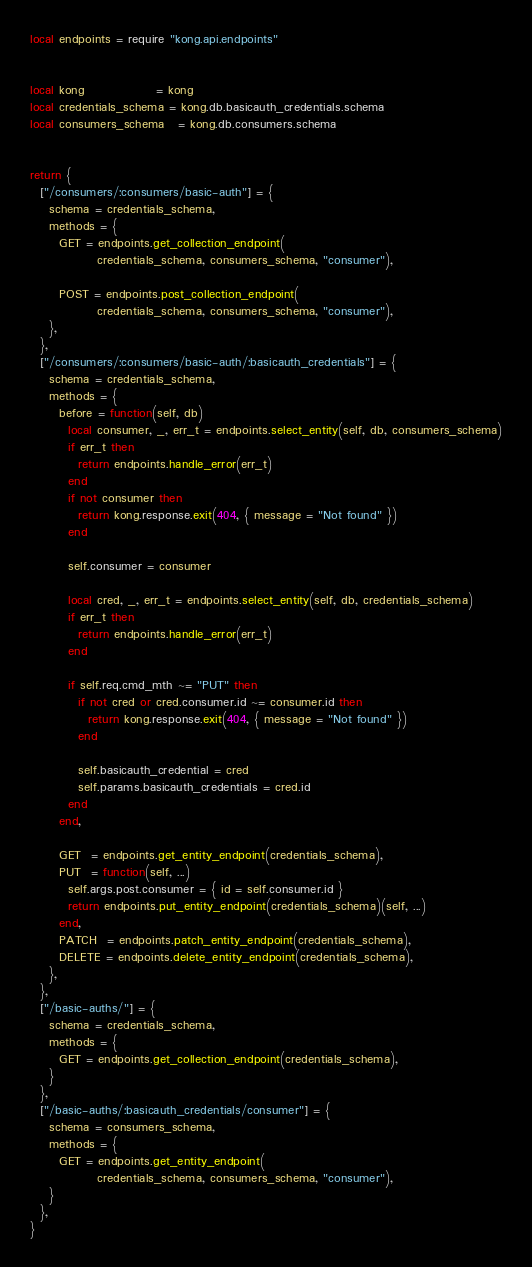<code> <loc_0><loc_0><loc_500><loc_500><_Lua_>local endpoints = require "kong.api.endpoints"


local kong               = kong
local credentials_schema = kong.db.basicauth_credentials.schema
local consumers_schema   = kong.db.consumers.schema


return {
  ["/consumers/:consumers/basic-auth"] = {
    schema = credentials_schema,
    methods = {
      GET = endpoints.get_collection_endpoint(
              credentials_schema, consumers_schema, "consumer"),

      POST = endpoints.post_collection_endpoint(
              credentials_schema, consumers_schema, "consumer"),
    },
  },
  ["/consumers/:consumers/basic-auth/:basicauth_credentials"] = {
    schema = credentials_schema,
    methods = {
      before = function(self, db)
        local consumer, _, err_t = endpoints.select_entity(self, db, consumers_schema)
        if err_t then
          return endpoints.handle_error(err_t)
        end
        if not consumer then
          return kong.response.exit(404, { message = "Not found" })
        end

        self.consumer = consumer

        local cred, _, err_t = endpoints.select_entity(self, db, credentials_schema)
        if err_t then
          return endpoints.handle_error(err_t)
        end

        if self.req.cmd_mth ~= "PUT" then
          if not cred or cred.consumer.id ~= consumer.id then
            return kong.response.exit(404, { message = "Not found" })
          end

          self.basicauth_credential = cred
          self.params.basicauth_credentials = cred.id
        end
      end,

      GET  = endpoints.get_entity_endpoint(credentials_schema),
      PUT  = function(self, ...)
        self.args.post.consumer = { id = self.consumer.id }
        return endpoints.put_entity_endpoint(credentials_schema)(self, ...)
      end,
      PATCH  = endpoints.patch_entity_endpoint(credentials_schema),
      DELETE = endpoints.delete_entity_endpoint(credentials_schema),
    },
  },
  ["/basic-auths/"] = {
    schema = credentials_schema,
    methods = {
      GET = endpoints.get_collection_endpoint(credentials_schema),
    }
  },
  ["/basic-auths/:basicauth_credentials/consumer"] = {
    schema = consumers_schema,
    methods = {
      GET = endpoints.get_entity_endpoint(
              credentials_schema, consumers_schema, "consumer"),
    }
  },
}
</code> 